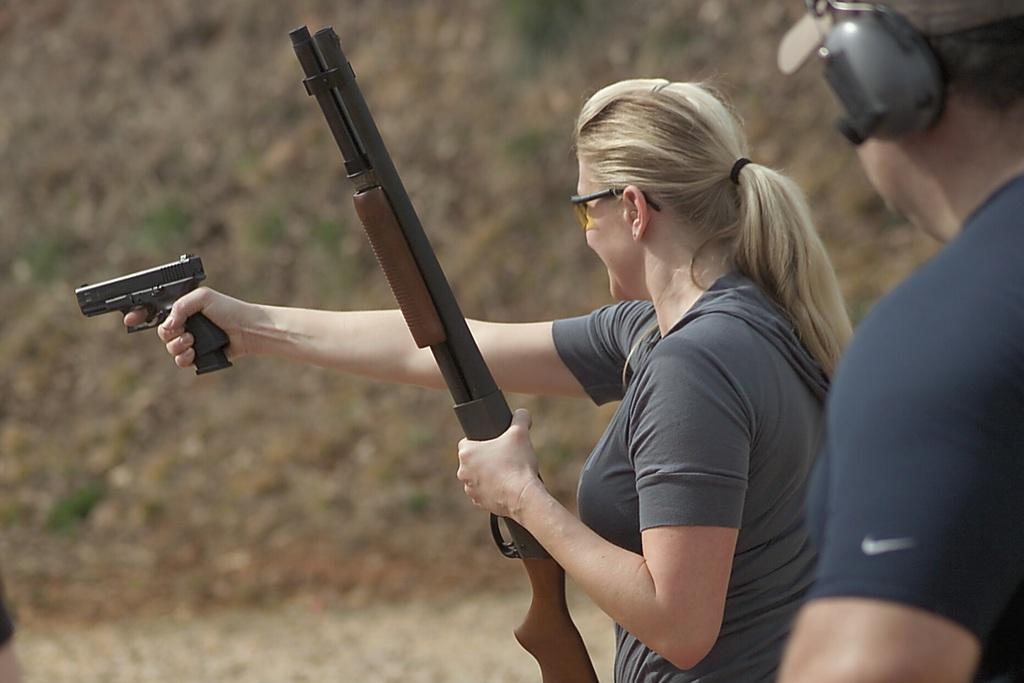What is the primary subject of the image? There is a woman standing in the image. What is the woman holding in her hands? The woman is holding two weapons in her hands. Can you describe the man in the image? There is a man standing on the right side of the image. How would you describe the background of the image? The background of the image appears blurry. What type of memory is the woman trying to recall in the image? There is no indication in the image that the woman is trying to recall a memory, as she is holding weapons and not engaged in any activity related to memory. 